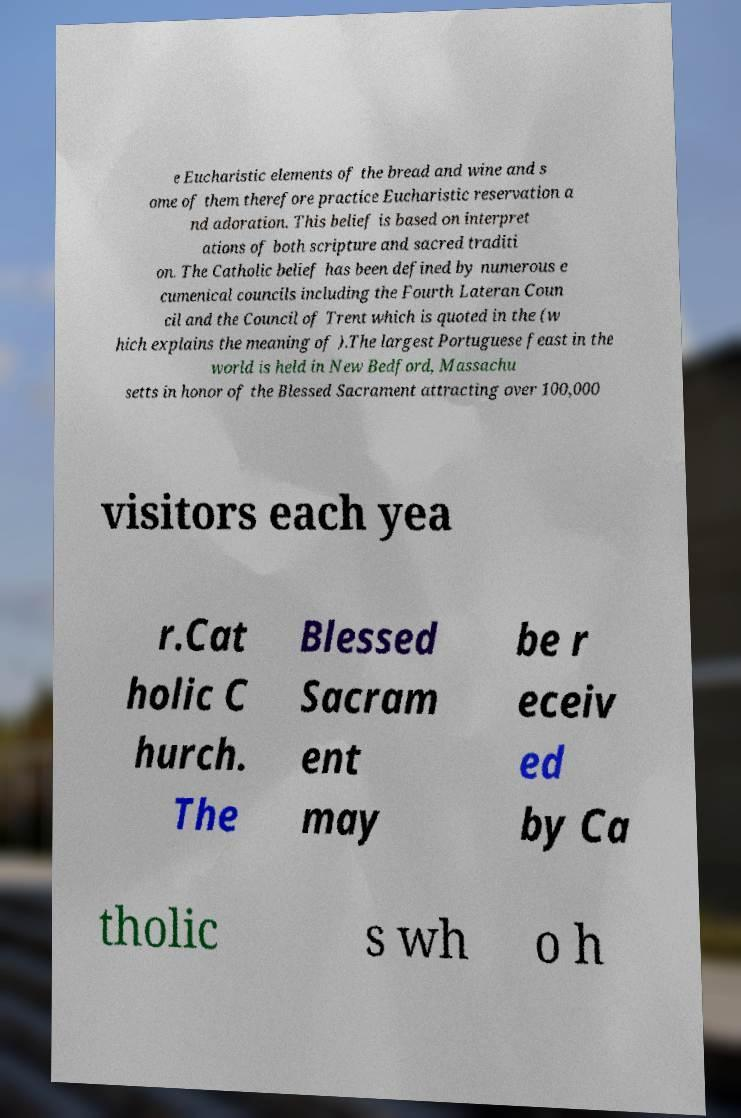Could you assist in decoding the text presented in this image and type it out clearly? e Eucharistic elements of the bread and wine and s ome of them therefore practice Eucharistic reservation a nd adoration. This belief is based on interpret ations of both scripture and sacred traditi on. The Catholic belief has been defined by numerous e cumenical councils including the Fourth Lateran Coun cil and the Council of Trent which is quoted in the (w hich explains the meaning of ).The largest Portuguese feast in the world is held in New Bedford, Massachu setts in honor of the Blessed Sacrament attracting over 100,000 visitors each yea r.Cat holic C hurch. The Blessed Sacram ent may be r eceiv ed by Ca tholic s wh o h 